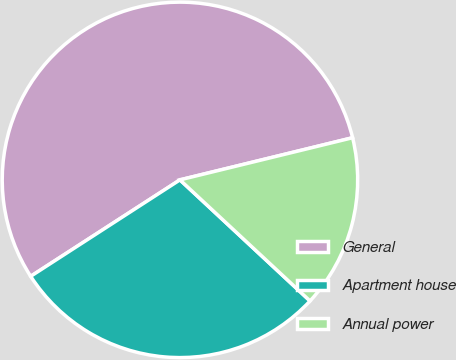Convert chart to OTSL. <chart><loc_0><loc_0><loc_500><loc_500><pie_chart><fcel>General<fcel>Apartment house<fcel>Annual power<nl><fcel>55.32%<fcel>28.94%<fcel>15.74%<nl></chart> 